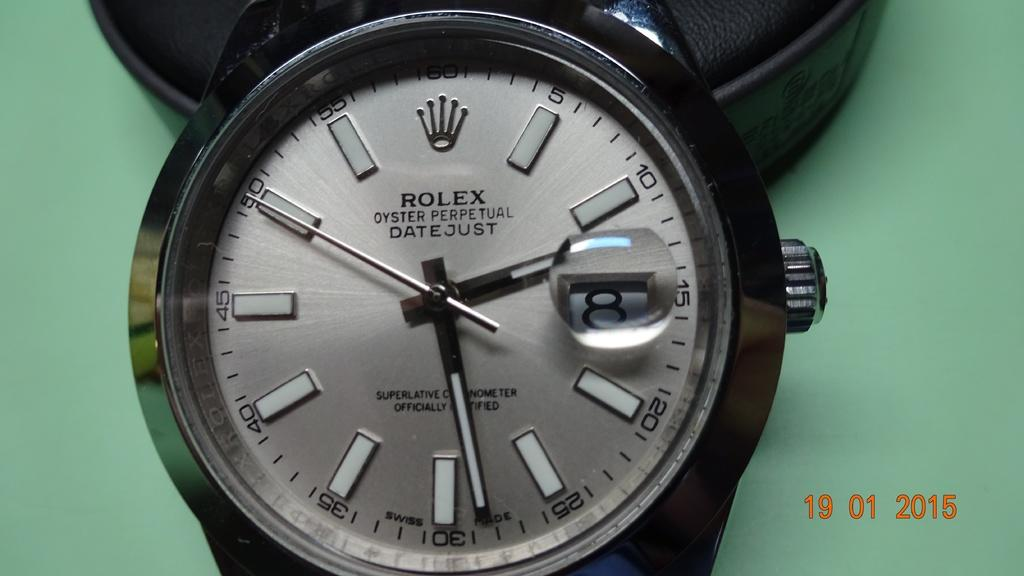<image>
Present a compact description of the photo's key features. A Rolex watch is sitting on a green background. 